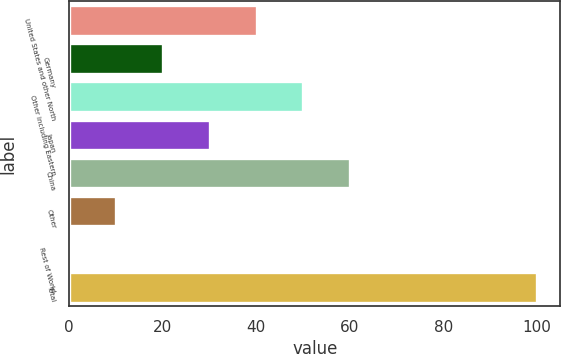<chart> <loc_0><loc_0><loc_500><loc_500><bar_chart><fcel>United States and other North<fcel>Germany<fcel>Other including Eastern<fcel>Japan<fcel>China<fcel>Other<fcel>Rest of World<fcel>Total<nl><fcel>40.06<fcel>20.08<fcel>50.05<fcel>30.07<fcel>60.04<fcel>10.09<fcel>0.1<fcel>100<nl></chart> 